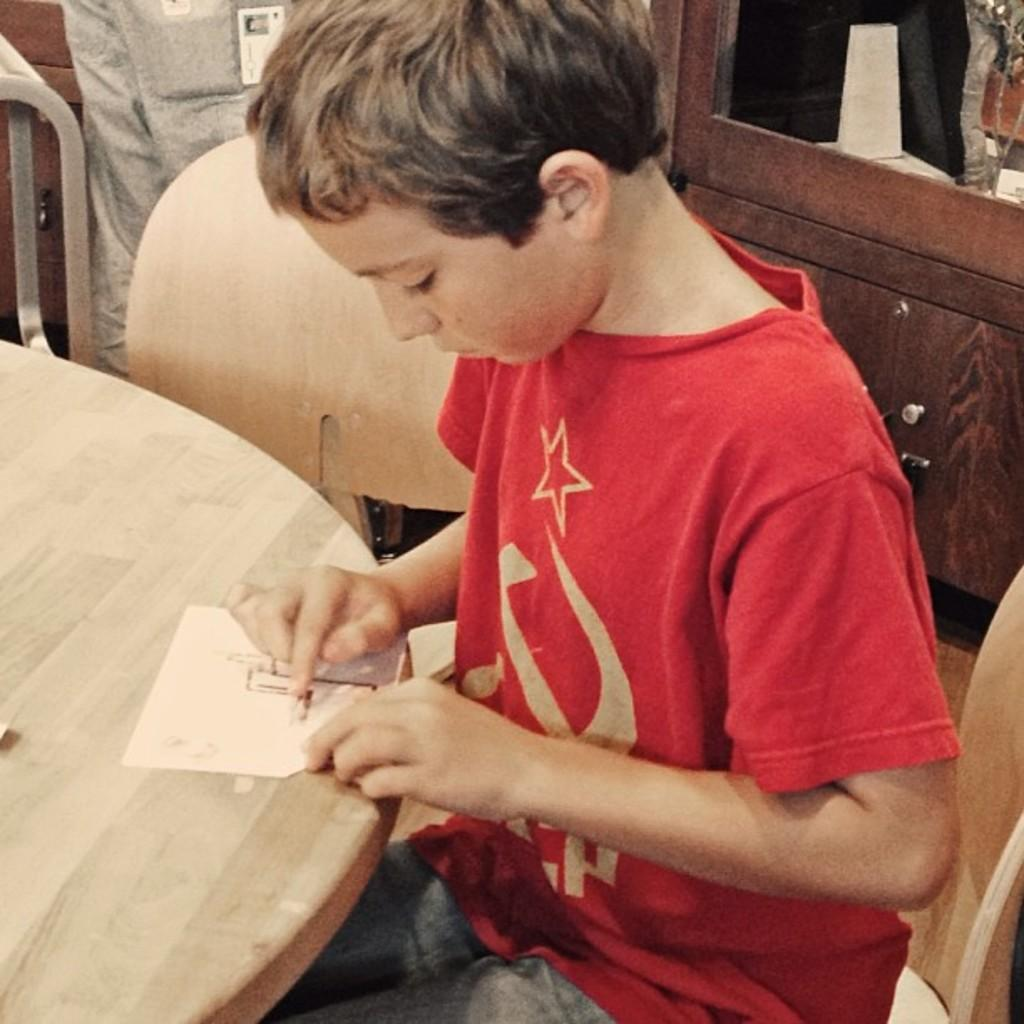Who is the main subject in the image? There is a boy in the image. What is the boy doing in the image? The boy is sitting on a chair. What other objects can be seen in the image? There is a table in the image. What is on the table? There is a paper on the table. What color is the boy's skirt in the image? The boy is not wearing a skirt in the image, as the facts do not mention any clothing items. 